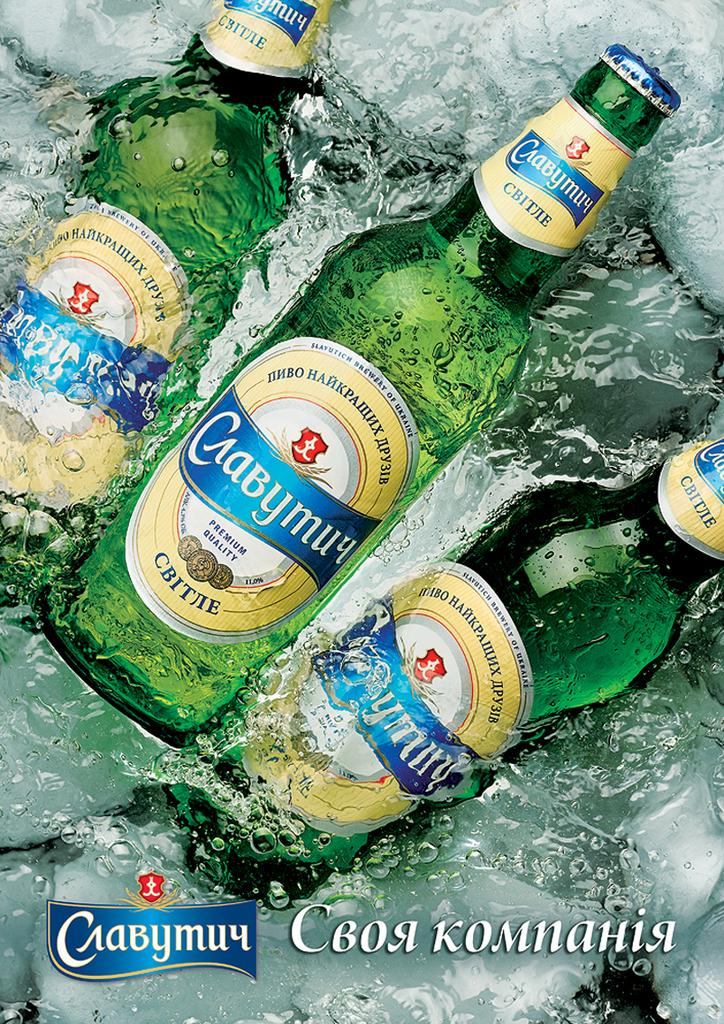<image>
Share a concise interpretation of the image provided. A few bottles of premium quality beverages in a tub of ice water claim they were brewed in the Ukraine. 